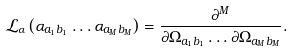Convert formula to latex. <formula><loc_0><loc_0><loc_500><loc_500>\mathcal { L } _ { \alpha } \left ( \alpha _ { a _ { 1 } b _ { 1 } } \dots \alpha _ { a _ { M } b _ { M } } \right ) & = \frac { \partial ^ { M } } { \partial \Omega _ { a _ { 1 } b _ { 1 } } \dots \partial \Omega _ { a _ { M } b _ { M } } } .</formula> 